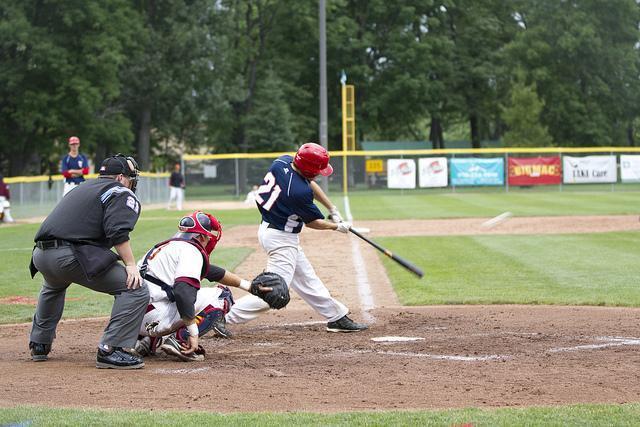How many people are there?
Give a very brief answer. 3. How many cows are in the scene?
Give a very brief answer. 0. 